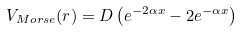Convert formula to latex. <formula><loc_0><loc_0><loc_500><loc_500>V _ { M o r s e } ( r ) = D \left ( e ^ { - 2 \alpha x } - 2 e ^ { - \alpha x } \right )</formula> 